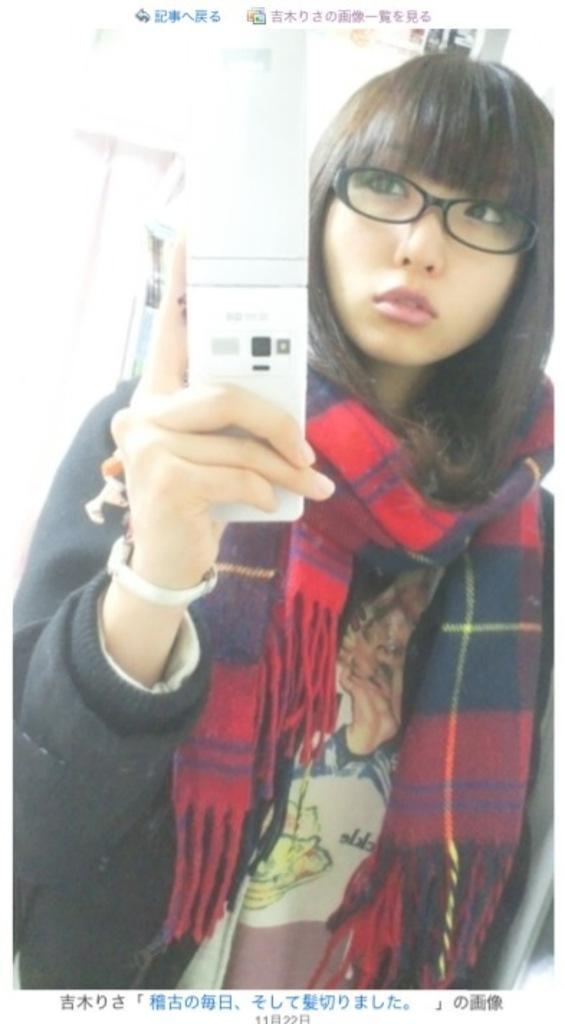Could you give a brief overview of what you see in this image? In this image a woman wearing a scarf and spectacles. She is holding a device in her hand. Bottom of the image there is some text. 